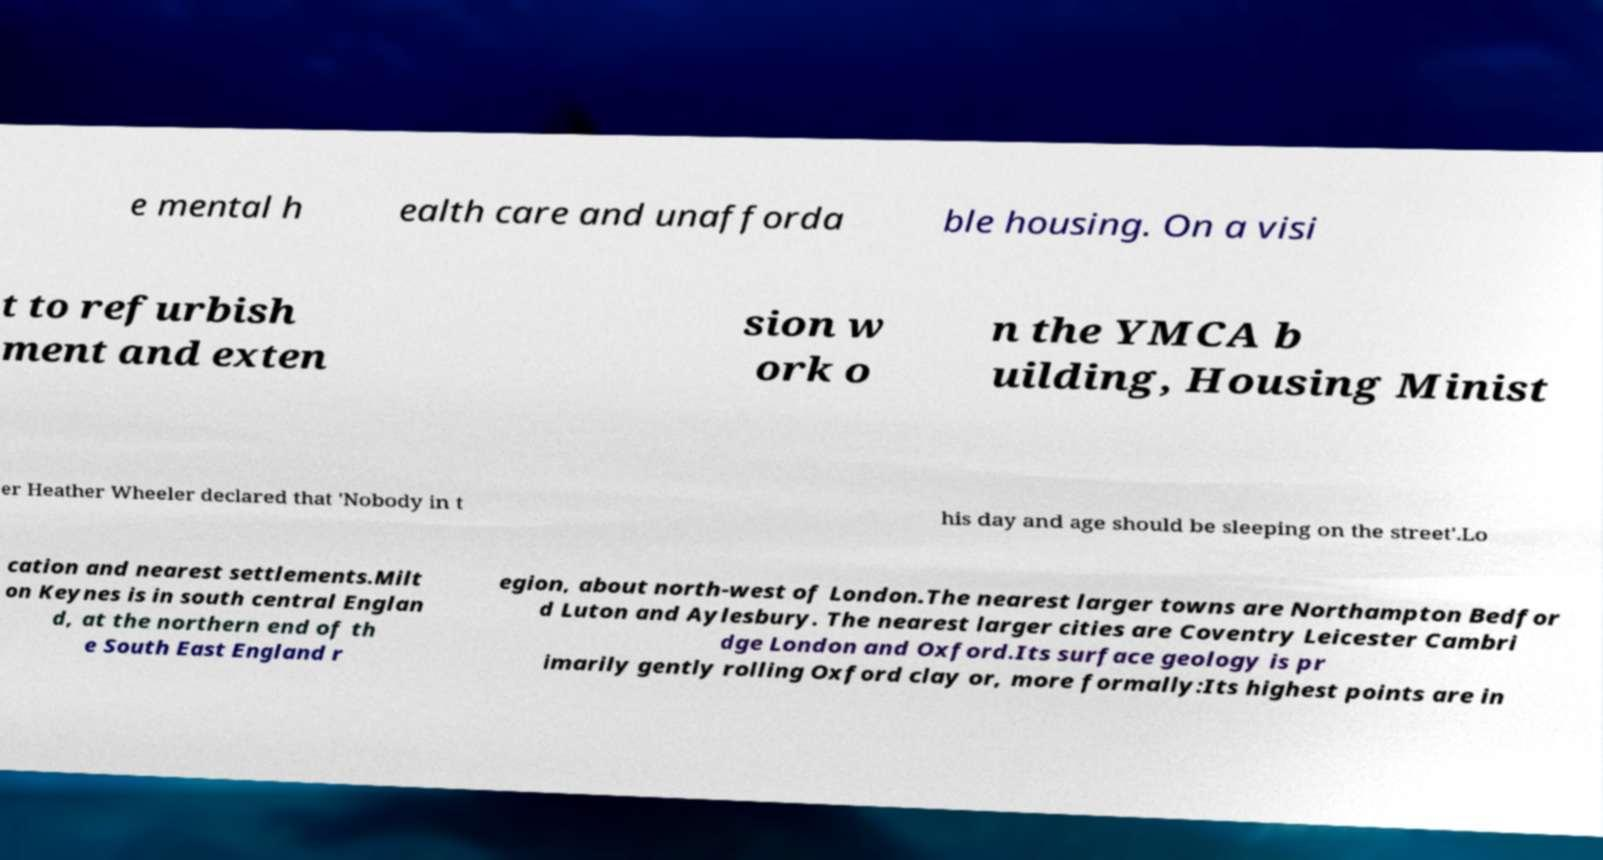For documentation purposes, I need the text within this image transcribed. Could you provide that? e mental h ealth care and unafforda ble housing. On a visi t to refurbish ment and exten sion w ork o n the YMCA b uilding, Housing Minist er Heather Wheeler declared that 'Nobody in t his day and age should be sleeping on the street'.Lo cation and nearest settlements.Milt on Keynes is in south central Englan d, at the northern end of th e South East England r egion, about north-west of London.The nearest larger towns are Northampton Bedfor d Luton and Aylesbury. The nearest larger cities are Coventry Leicester Cambri dge London and Oxford.Its surface geology is pr imarily gently rolling Oxford clay or, more formally:Its highest points are in 